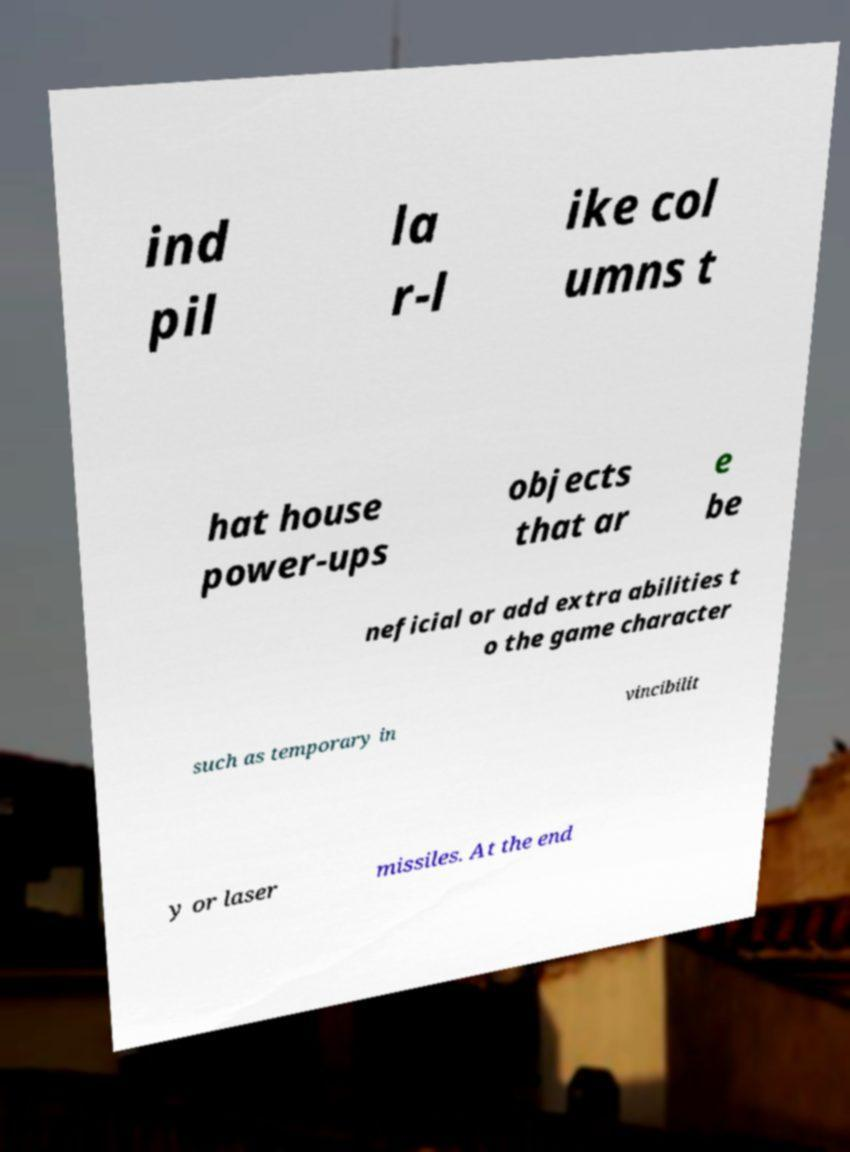Can you read and provide the text displayed in the image?This photo seems to have some interesting text. Can you extract and type it out for me? ind pil la r-l ike col umns t hat house power-ups objects that ar e be neficial or add extra abilities t o the game character such as temporary in vincibilit y or laser missiles. At the end 